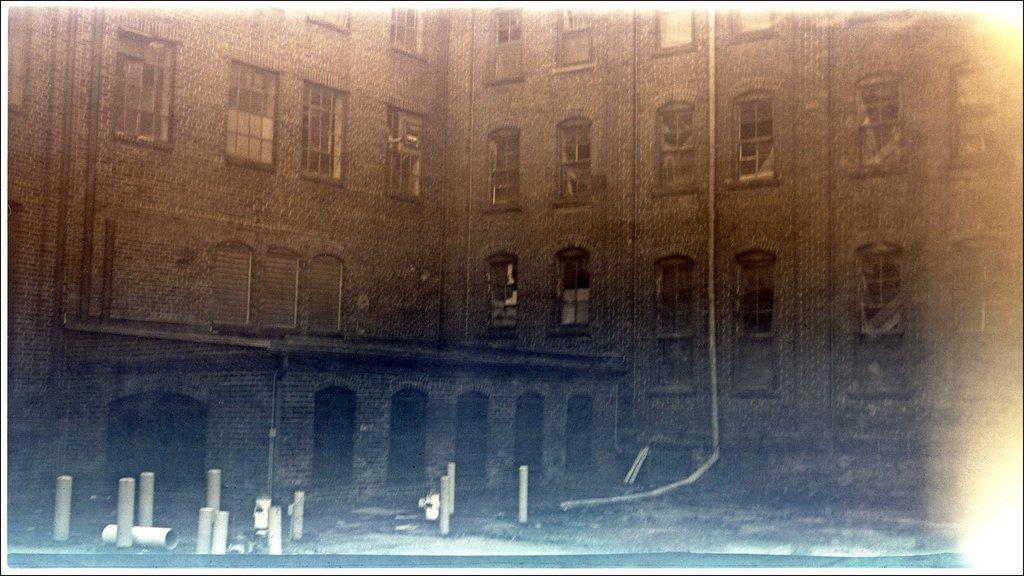What is the main structure visible in the image? There is a building in the picture. Can you describe any specific features of the building? Unfortunately, the provided facts do not mention any specific features of the building. What else can be seen in the image besides the building? There are pipes in the bottom left of the image. Can you tell me how many trays are being used by the expert in the image? There is no expert or tray present in the image; it only features a building and pipes. 